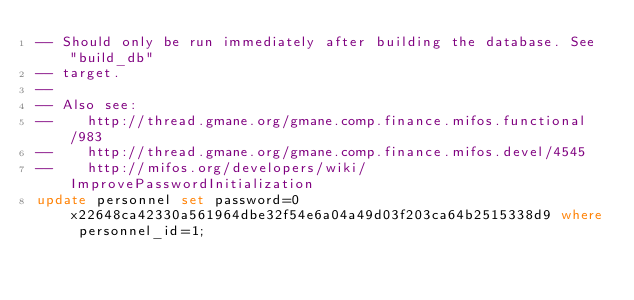Convert code to text. <code><loc_0><loc_0><loc_500><loc_500><_SQL_>-- Should only be run immediately after building the database. See "build_db"
-- target.
--
-- Also see:
--    http://thread.gmane.org/gmane.comp.finance.mifos.functional/983
--    http://thread.gmane.org/gmane.comp.finance.mifos.devel/4545
--    http://mifos.org/developers/wiki/ImprovePasswordInitialization
update personnel set password=0x22648ca42330a561964dbe32f54e6a04a49d03f203ca64b2515338d9 where personnel_id=1;
</code> 